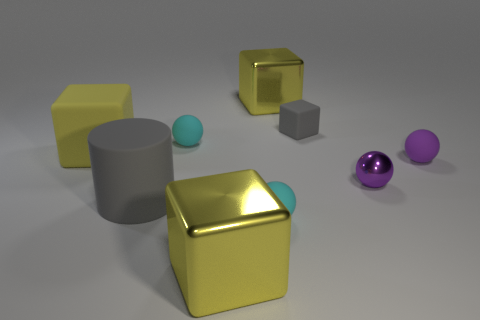Subtract all red balls. How many yellow blocks are left? 3 Subtract 1 spheres. How many spheres are left? 3 Add 1 large brown blocks. How many objects exist? 10 Subtract all blocks. How many objects are left? 5 Add 6 matte blocks. How many matte blocks are left? 8 Add 1 small blue cylinders. How many small blue cylinders exist? 1 Subtract 0 brown cubes. How many objects are left? 9 Subtract all cyan matte blocks. Subtract all gray matte cylinders. How many objects are left? 8 